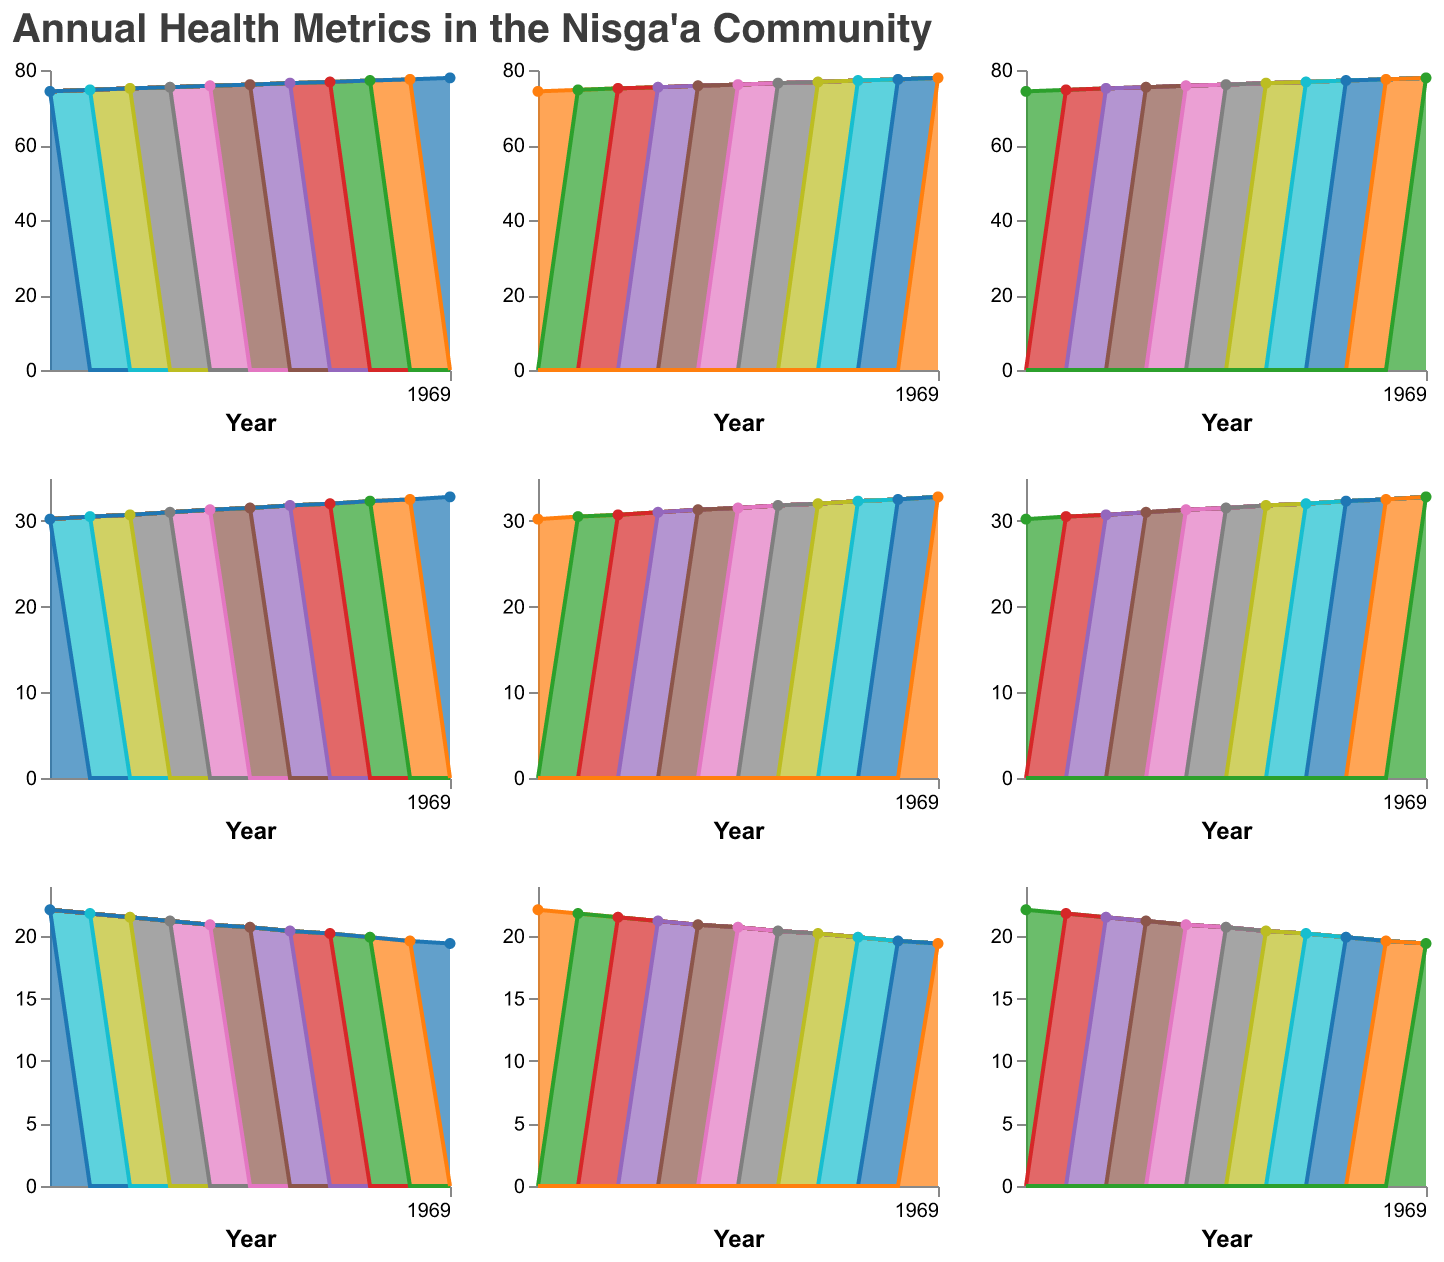What is the title of the figure? The title is displayed at the top of the figure.
Answer: Annual Health Metrics in the Nisga’a Community How many different metrics are plotted in the figure? Each row and column represent a different metric; therefore, counting the distinct metrics will give us the total number.
Answer: 6 Which metric has the highest value in 2020? By identifying the metric with the highest value in 2020 across all subplots, we can determine which one it is. Obesity_Rate is the highest at 32.8%.
Answer: Obesity_Rate By how much has Life_Expectancy increased from 2010 to 2020? Identify the Life_Expectancy values for 2010 and 2020, then calculate the difference: 77.9 - 74.3.
Answer: 3.6 years Which metric shows a decreasing trend from 2010 to 2020? Looking at each subplot and identifying trends, the Smoking_Rate consistently decreases from 22.1% to 19.4%.
Answer: Smoking_Rate What is the average Infant_Mortality_Rate over the displayed years? Sum all the Infant_Mortality_Rate values from 2010 to 2020 and divide by the number of years: (5.2 + 5.1 + 5.0 + 4.8 + 4.7 + 4.6 + 4.4 + 4.3 + 4.2 + 4.0 + 3.9) / 11.
Answer: 4.65 Compare the Diabetes_Prevalence in 2015 and 2020. Has it increased or decreased? By comparing the Diabetes_Prevalence values for the two years: 15.0% in 2020 and 13.8% in 2015, we see it has increased.
Answer: Increased Which metric has the smallest range of values over the years? Calculate the range (max - min) for each metric and determine which one is the smallest. In this case, the Infant_Mortality_Rate has the smallest range (5.2 - 3.9).
Answer: Infant_Mortality_Rate Which year shows the lowest value for Mental_Health_Issues? Identify the values for Mental_Health_Issues and find the lowest one, which occurs in 2010 at 18.9%.
Answer: 2010 